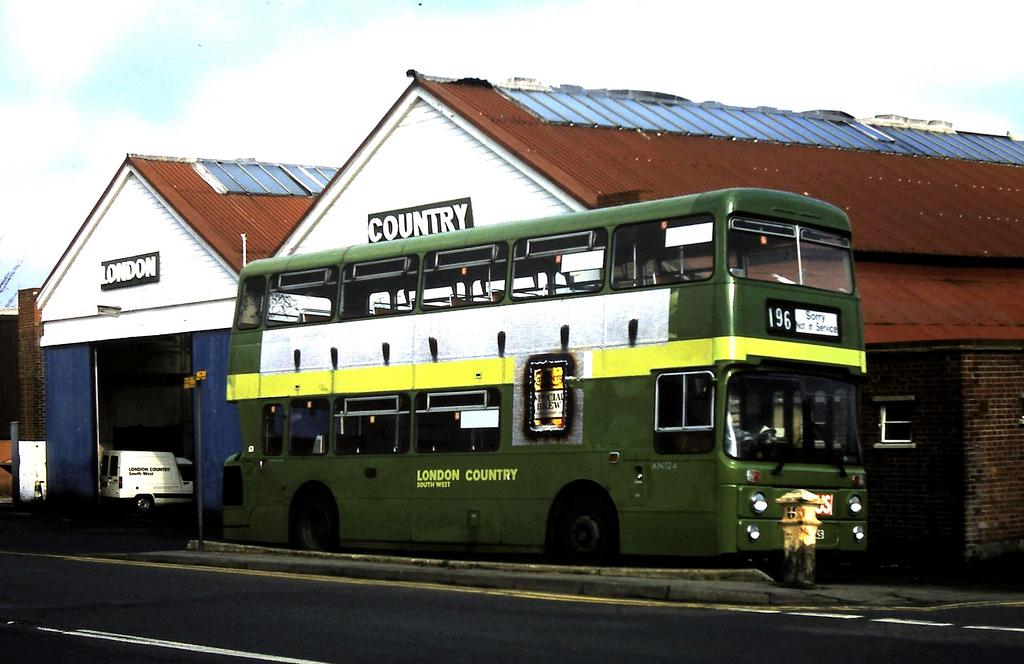Question: when was this taken?
Choices:
A. At night.
B. At sunrise.
C. Broad daylight.
D. At sunset.
Answer with the letter. Answer: C Question: what is the bus number?
Choices:
A. 210.
B. 196.
C. 40.
D. 2.
Answer with the letter. Answer: B Question: what is this?
Choices:
A. A double decker bus.
B. A bowl of fruit.
C. A laptop.
D. A cake.
Answer with the letter. Answer: A Question: where is it?
Choices:
A. Rome.
B. Vienna.
C. New York.
D. London.
Answer with the letter. Answer: D Question: why is it there?
Choices:
A. To advertise companies.
B. To carry tourists around.
C. For emergency evacuations.
D. To get people to work.
Answer with the letter. Answer: B Question: what is in the garage?
Choices:
A. Bikes.
B. There is a van in the garage.
C. A lol of junk.
D. Washer and dryer.
Answer with the letter. Answer: B Question: what color is the front walls on the garage?
Choices:
A. There are not any front walls just the white garage door.
B. The front wall is white.
C. The wall is green.
D. The garage has blue lower front walls.
Answer with the letter. Answer: D Question: what has solar panels?
Choices:
A. Bus.
B. Building next to bus.
C. Street sign.
D. Stop light.
Answer with the letter. Answer: B Question: what is green, yellow and white?
Choices:
A. Car.
B. Bicycle.
C. Building.
D. Bus.
Answer with the letter. Answer: D Question: how many garages are in building?
Choices:
A. Three.
B. Four.
C. Eight.
D. Two.
Answer with the letter. Answer: D Question: what is on top of roof?
Choices:
A. Sign.
B. Birds.
C. Solar panels.
D. Children.
Answer with the letter. Answer: C Question: what color is the bus?
Choices:
A. Dark green with yellow stripe and white section.
B. Red.
C. Blue.
D. Gray and yellow.
Answer with the letter. Answer: A Question: how many levels does bus have?
Choices:
A. One.
B. Two.
C. Three.
D. Four.
Answer with the letter. Answer: B Question: what do the garages say?
Choices:
A. London and Country.
B. Park inside.
C. Leave your car.
D. You need tires.
Answer with the letter. Answer: A Question: what kind of bus station is it?
Choices:
A. A London Country station.
B. Local.
C. A greyhound.
D. Commuter.
Answer with the letter. Answer: A Question: what is in front of the bus?
Choices:
A. A stop sign.
B. The bus number.
C. A fire hydrant.
D. Where it is going.
Answer with the letter. Answer: C 